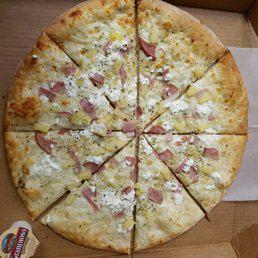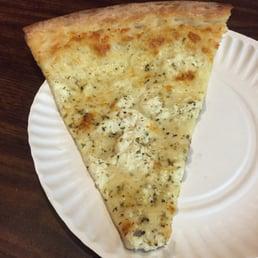The first image is the image on the left, the second image is the image on the right. For the images displayed, is the sentence "There is pizza on a paper plate." factually correct? Answer yes or no. Yes. The first image is the image on the left, the second image is the image on the right. Considering the images on both sides, is "One image shows a complete round pizza, and the other image features at least one pizza slice on a white paper plate." valid? Answer yes or no. Yes. 